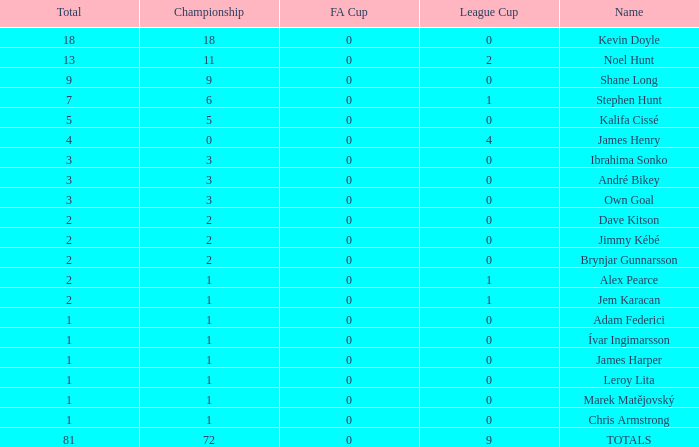Give me the full table as a dictionary. {'header': ['Total', 'Championship', 'FA Cup', 'League Cup', 'Name'], 'rows': [['18', '18', '0', '0', 'Kevin Doyle'], ['13', '11', '0', '2', 'Noel Hunt'], ['9', '9', '0', '0', 'Shane Long'], ['7', '6', '0', '1', 'Stephen Hunt'], ['5', '5', '0', '0', 'Kalifa Cissé'], ['4', '0', '0', '4', 'James Henry'], ['3', '3', '0', '0', 'Ibrahima Sonko'], ['3', '3', '0', '0', 'André Bikey'], ['3', '3', '0', '0', 'Own Goal'], ['2', '2', '0', '0', 'Dave Kitson'], ['2', '2', '0', '0', 'Jimmy Kébé'], ['2', '2', '0', '0', 'Brynjar Gunnarsson'], ['2', '1', '0', '1', 'Alex Pearce'], ['2', '1', '0', '1', 'Jem Karacan'], ['1', '1', '0', '0', 'Adam Federici'], ['1', '1', '0', '0', 'Ívar Ingimarsson'], ['1', '1', '0', '0', 'James Harper'], ['1', '1', '0', '0', 'Leroy Lita'], ['1', '1', '0', '0', 'Marek Matějovský'], ['1', '1', '0', '0', 'Chris Armstrong'], ['81', '72', '0', '9', 'TOTALS']]} What is the total championships of James Henry that has a league cup more than 1? 0.0. 